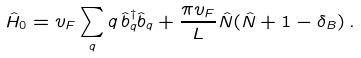<formula> <loc_0><loc_0><loc_500><loc_500>\hat { H } _ { 0 } = v _ { F } \sum _ { q } q \, \hat { b } ^ { \dag } _ { q } \hat { b } _ { q } + \frac { \pi v _ { F } } { L } \hat { N } ( \hat { N } + 1 - \delta _ { B } ) \, .</formula> 